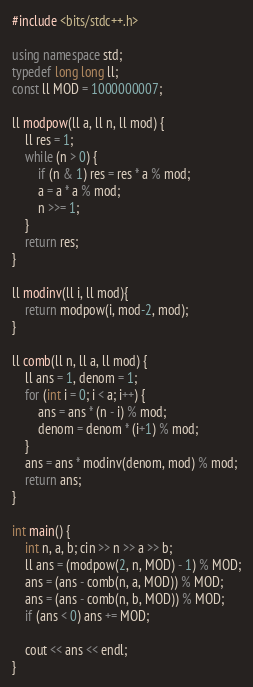<code> <loc_0><loc_0><loc_500><loc_500><_C++_>#include <bits/stdc++.h>

using namespace std;
typedef long long ll;
const ll MOD = 1000000007;

ll modpow(ll a, ll n, ll mod) {
    ll res = 1;
    while (n > 0) {
        if (n & 1) res = res * a % mod;
        a = a * a % mod;
        n >>= 1;
    }
    return res;
}

ll modinv(ll i, ll mod){
    return modpow(i, mod-2, mod);
}

ll comb(ll n, ll a, ll mod) {
    ll ans = 1, denom = 1;
    for (int i = 0; i < a; i++) {
        ans = ans * (n - i) % mod;
        denom = denom * (i+1) % mod;
    }
    ans = ans * modinv(denom, mod) % mod;
    return ans;
}

int main() {
    int n, a, b; cin >> n >> a >> b;
    ll ans = (modpow(2, n, MOD) - 1) % MOD;
    ans = (ans - comb(n, a, MOD)) % MOD;
    ans = (ans - comb(n, b, MOD)) % MOD;
    if (ans < 0) ans += MOD;

    cout << ans << endl;
}
</code> 